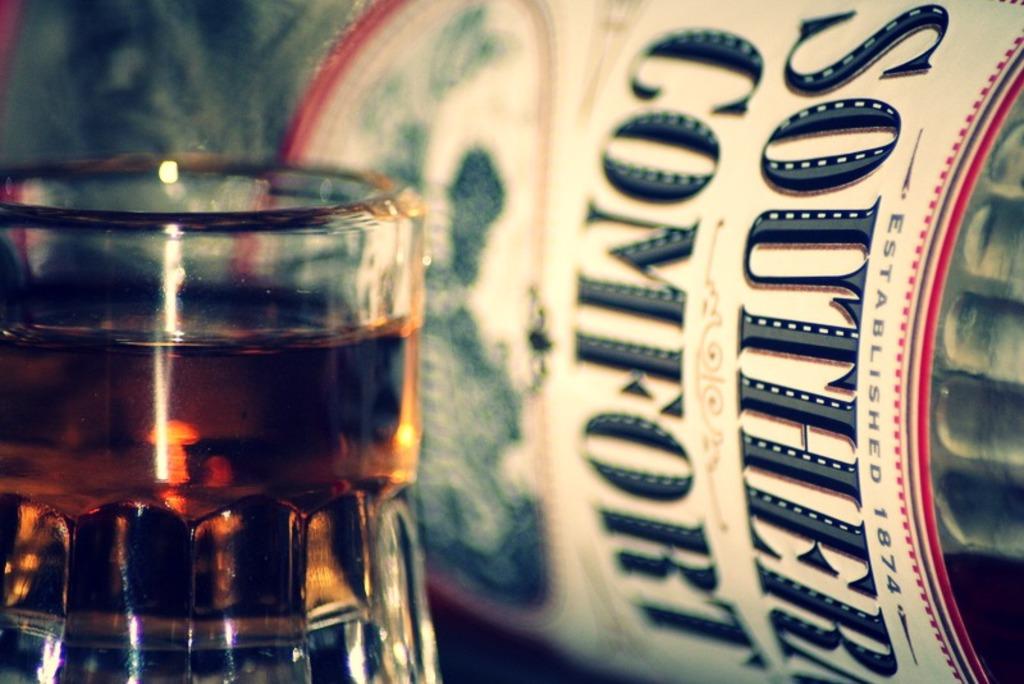What kind of alcohol is this?
Your answer should be very brief. Southern comfort. 